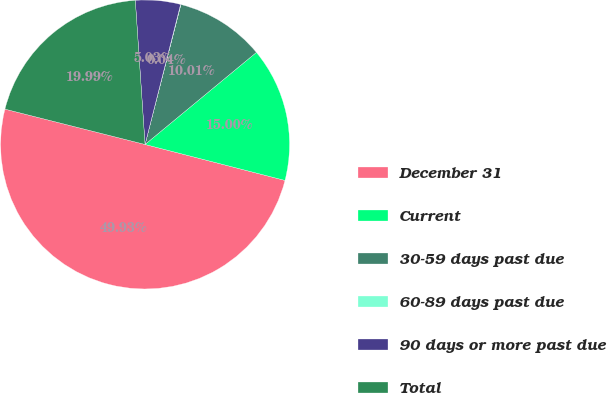Convert chart to OTSL. <chart><loc_0><loc_0><loc_500><loc_500><pie_chart><fcel>December 31<fcel>Current<fcel>30-59 days past due<fcel>60-89 days past due<fcel>90 days or more past due<fcel>Total<nl><fcel>49.93%<fcel>15.0%<fcel>10.01%<fcel>0.04%<fcel>5.03%<fcel>19.99%<nl></chart> 